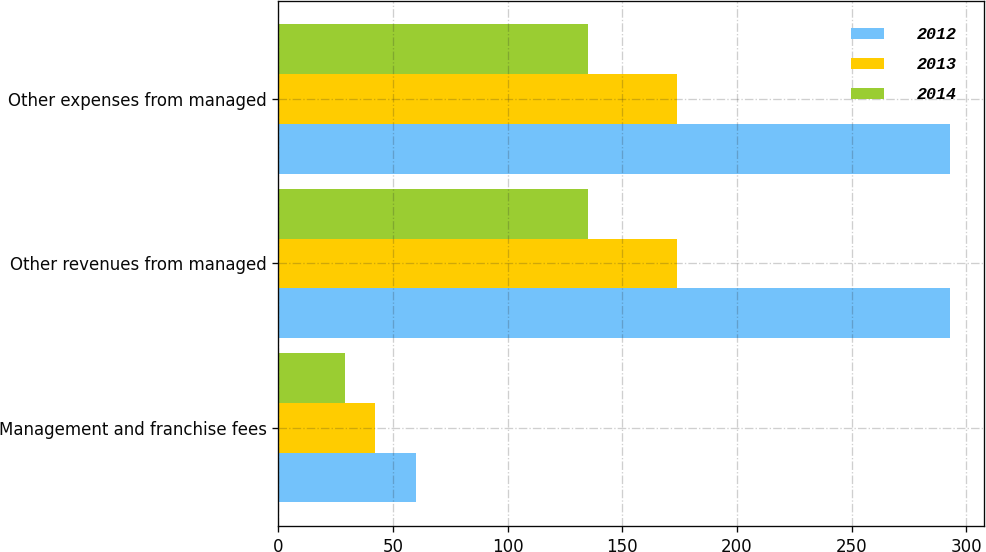<chart> <loc_0><loc_0><loc_500><loc_500><stacked_bar_chart><ecel><fcel>Management and franchise fees<fcel>Other revenues from managed<fcel>Other expenses from managed<nl><fcel>2012<fcel>60<fcel>293<fcel>293<nl><fcel>2013<fcel>42<fcel>174<fcel>174<nl><fcel>2014<fcel>29<fcel>135<fcel>135<nl></chart> 